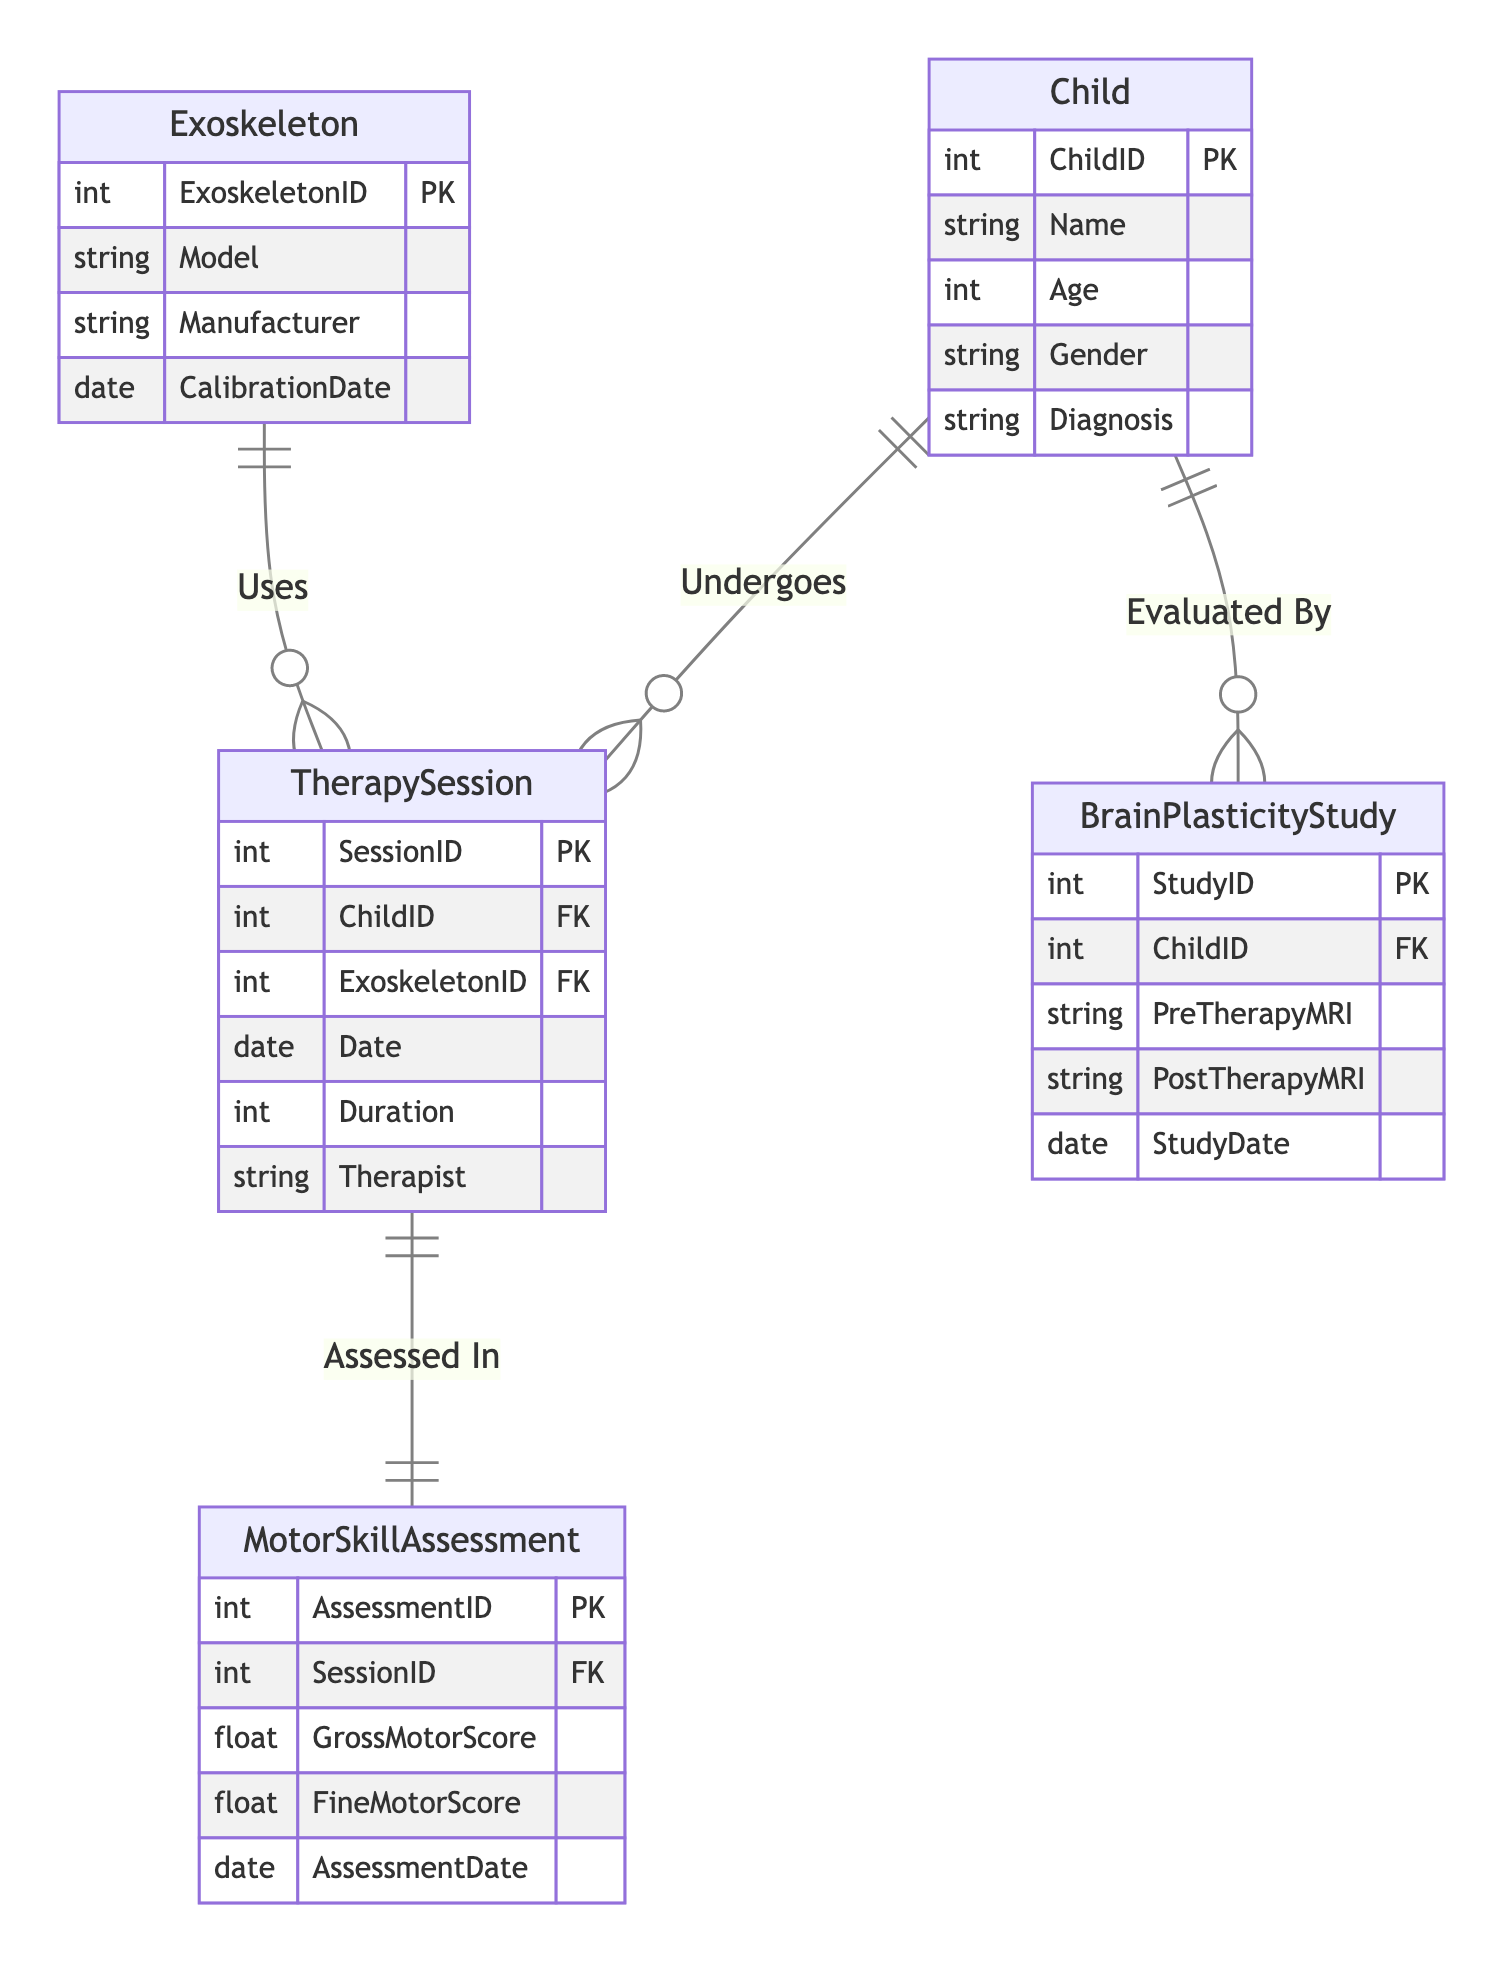What is the primary key for the Child entity? The primary key for the Child entity is ChildID, which uniquely identifies each child in the database.
Answer: ChildID How many relationships are there in the diagram? There are four relationships: Undergoes, Uses, Assessed In, and Evaluated By, linking the entities together in the diagram.
Answer: 4 What entities are related by the relationship "Undergoes"? The relationship "Undergoes" connects the Child and TherapySession entities, indicating that a child can undergo multiple therapy sessions.
Answer: Child, TherapySession What is the role of the Exoskeleton in the TherapySession? The Exoskeleton is used in the TherapySession as indicated by the "Uses" relationship, which shows that multiple therapy sessions can utilize the same exoskeleton.
Answer: Uses How many assessments can a single TherapySession have? A single TherapySession can have one assessment as indicated by the "Assessed In" relationship, which connects one session to one motor skill assessment.
Answer: 1 Which entity evaluates the Child in terms of brain plasticity? The BrainPlasticityStudy evaluates the Child's brain plasticity, as shown by the "Evaluated By" relationship between these two entities in the diagram.
Answer: BrainPlasticityStudy What is the foreign key in the MotorSkillAssessment entity? The foreign key in the MotorSkillAssessment entity is SessionID, linking each assessment to a specific therapy session.
Answer: SessionID What type of relationship exists between TherapySession and Exoskeleton? The relationship between TherapySession and Exoskeleton is "many to one," meaning many therapy sessions can involve a single exoskeleton.
Answer: many to one How is the motor skill assessment related to therapy sessions? The MotorSkillAssessment is directly related to TherapySession through the "Assessed In" relationship, indicating that each session has an associated assessment.
Answer: Assessed In 